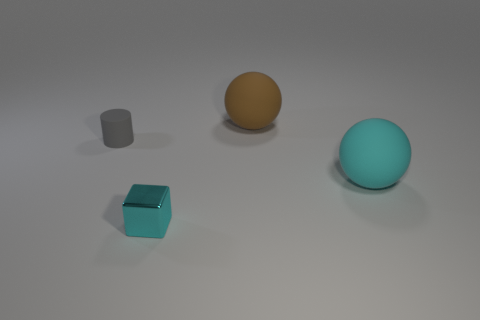Add 2 brown rubber things. How many objects exist? 6 Subtract all blocks. How many objects are left? 3 Subtract 0 gray balls. How many objects are left? 4 Subtract all blue rubber blocks. Subtract all metal blocks. How many objects are left? 3 Add 2 tiny rubber cylinders. How many tiny rubber cylinders are left? 3 Add 3 matte cylinders. How many matte cylinders exist? 4 